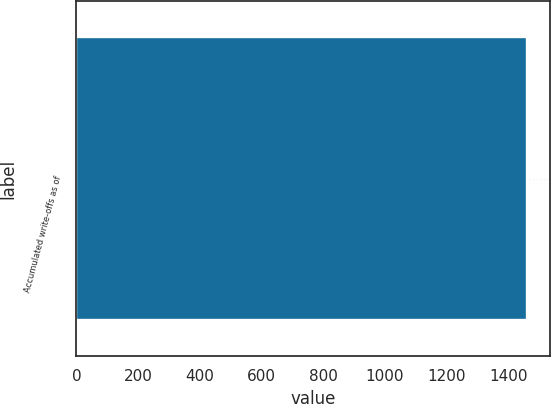<chart> <loc_0><loc_0><loc_500><loc_500><bar_chart><fcel>Accumulated write-offs as of<nl><fcel>1461.2<nl></chart> 